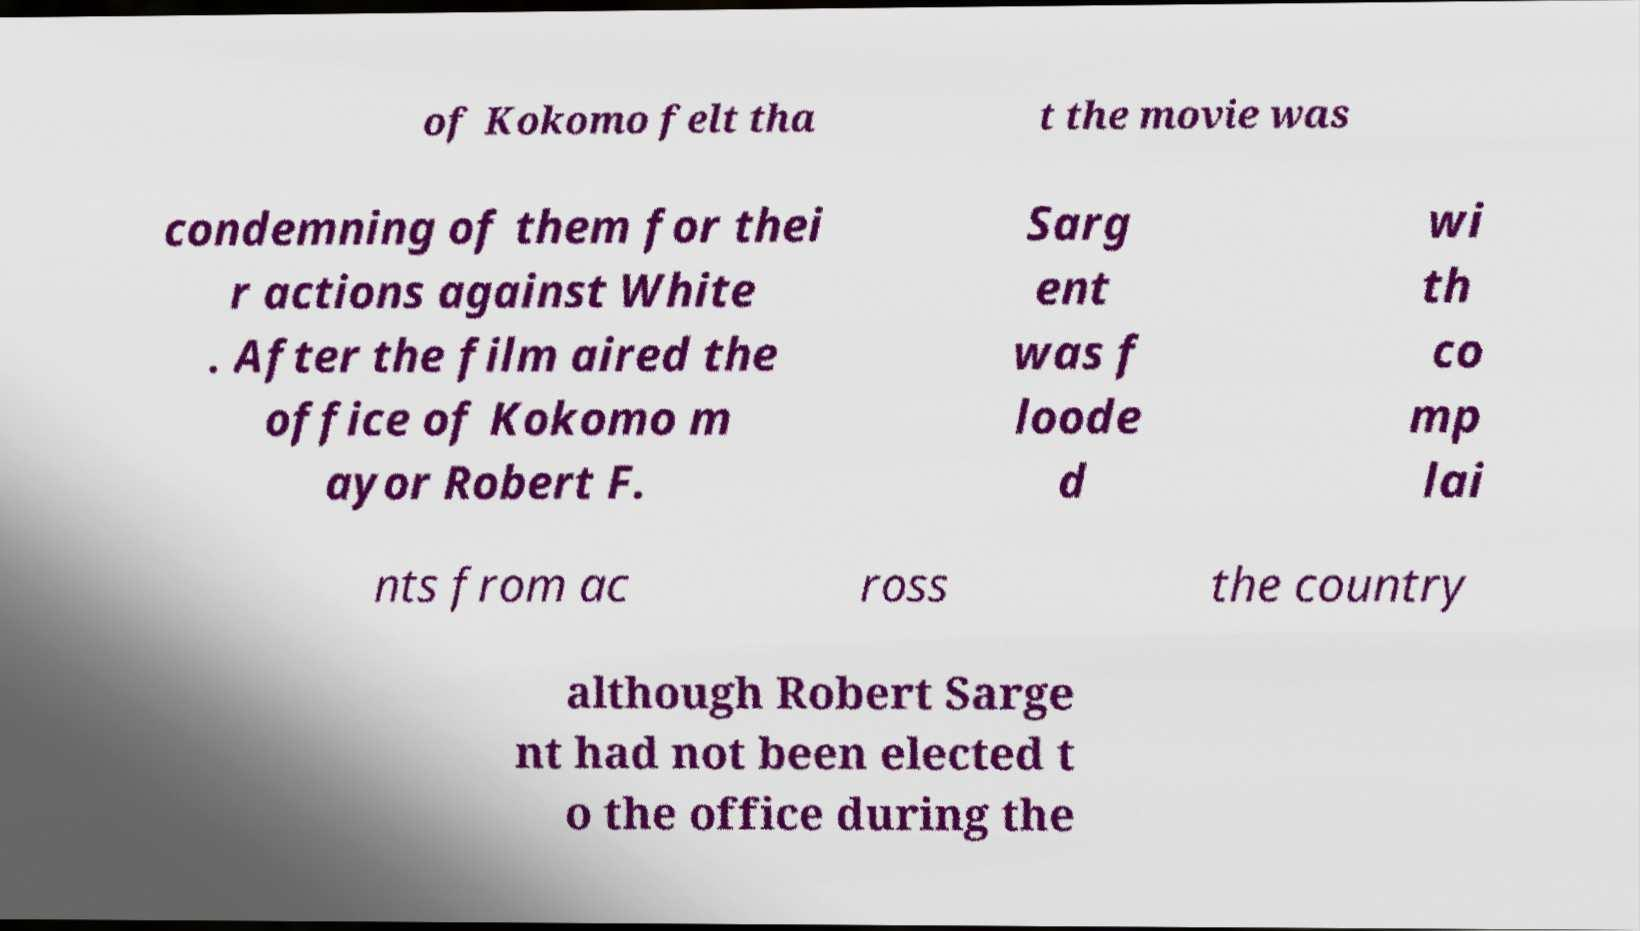Can you accurately transcribe the text from the provided image for me? of Kokomo felt tha t the movie was condemning of them for thei r actions against White . After the film aired the office of Kokomo m ayor Robert F. Sarg ent was f loode d wi th co mp lai nts from ac ross the country although Robert Sarge nt had not been elected t o the office during the 